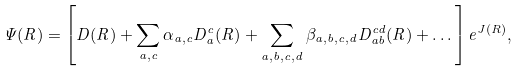<formula> <loc_0><loc_0><loc_500><loc_500>\Psi ( { R } ) = \left [ D ( { R } ) + \sum _ { a , c } \alpha _ { a , c } D _ { a } ^ { c } ( { R } ) + \sum _ { a , b , c , d } \beta _ { a , b , c , d } D _ { a b } ^ { c d } ( { R } ) + \dots \right ] e ^ { J ( { R } ) } ,</formula> 